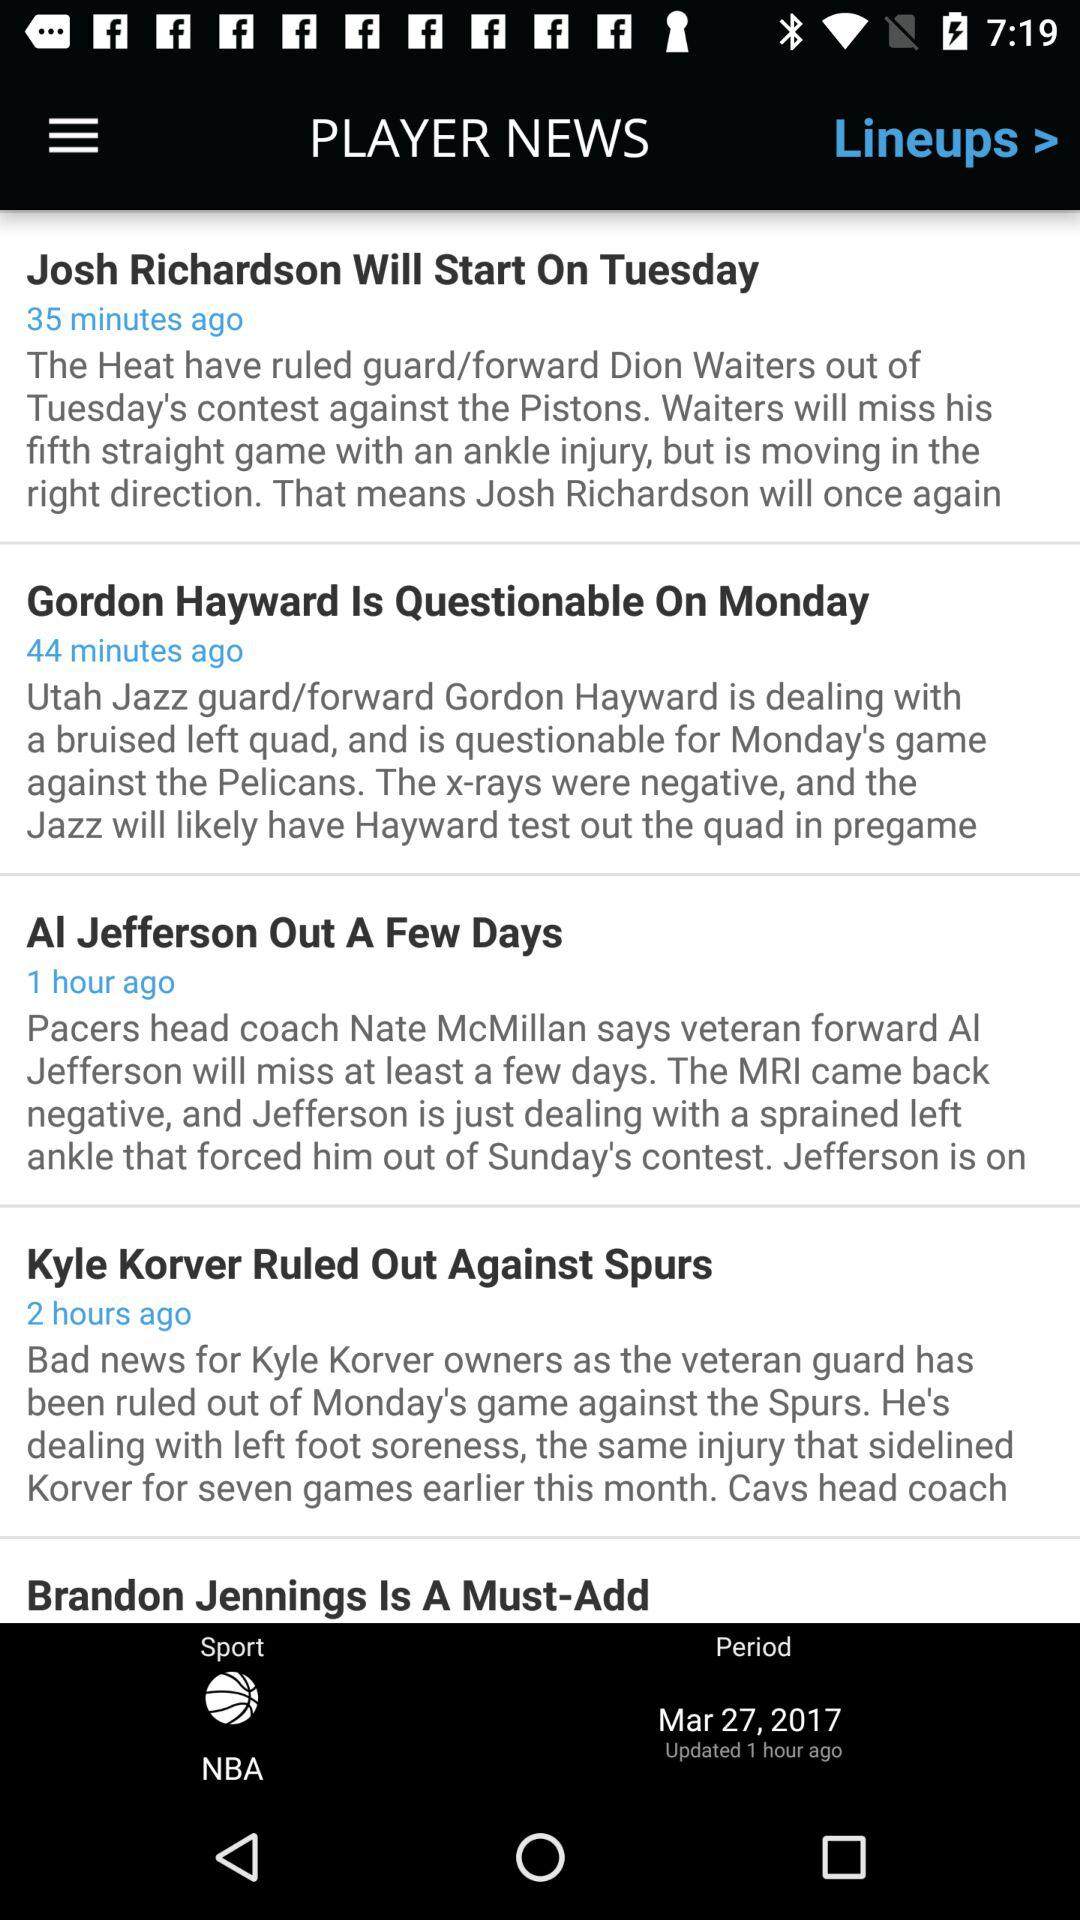When was the last time the Player News was updated? The last time Player News was updated was 1 hour ago, on March 27th, 2017. 